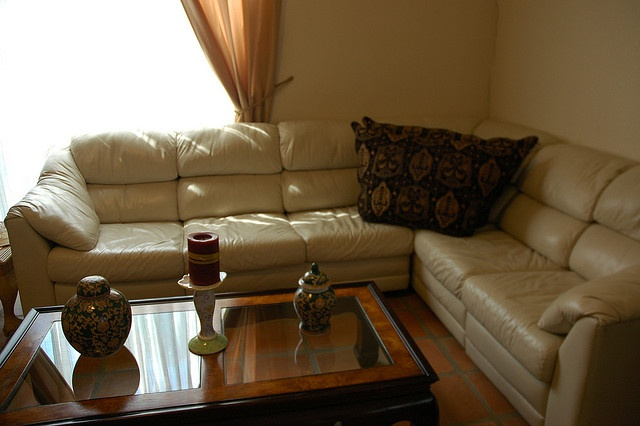Describe the objects in this image and their specific colors. I can see couch in ivory, olive, black, maroon, and gray tones, dining table in ivory, black, maroon, and lightgray tones, vase in ivory, black, maroon, and lightgray tones, vase in ivory, black, maroon, and gray tones, and vase in ivory, olive, black, and white tones in this image. 